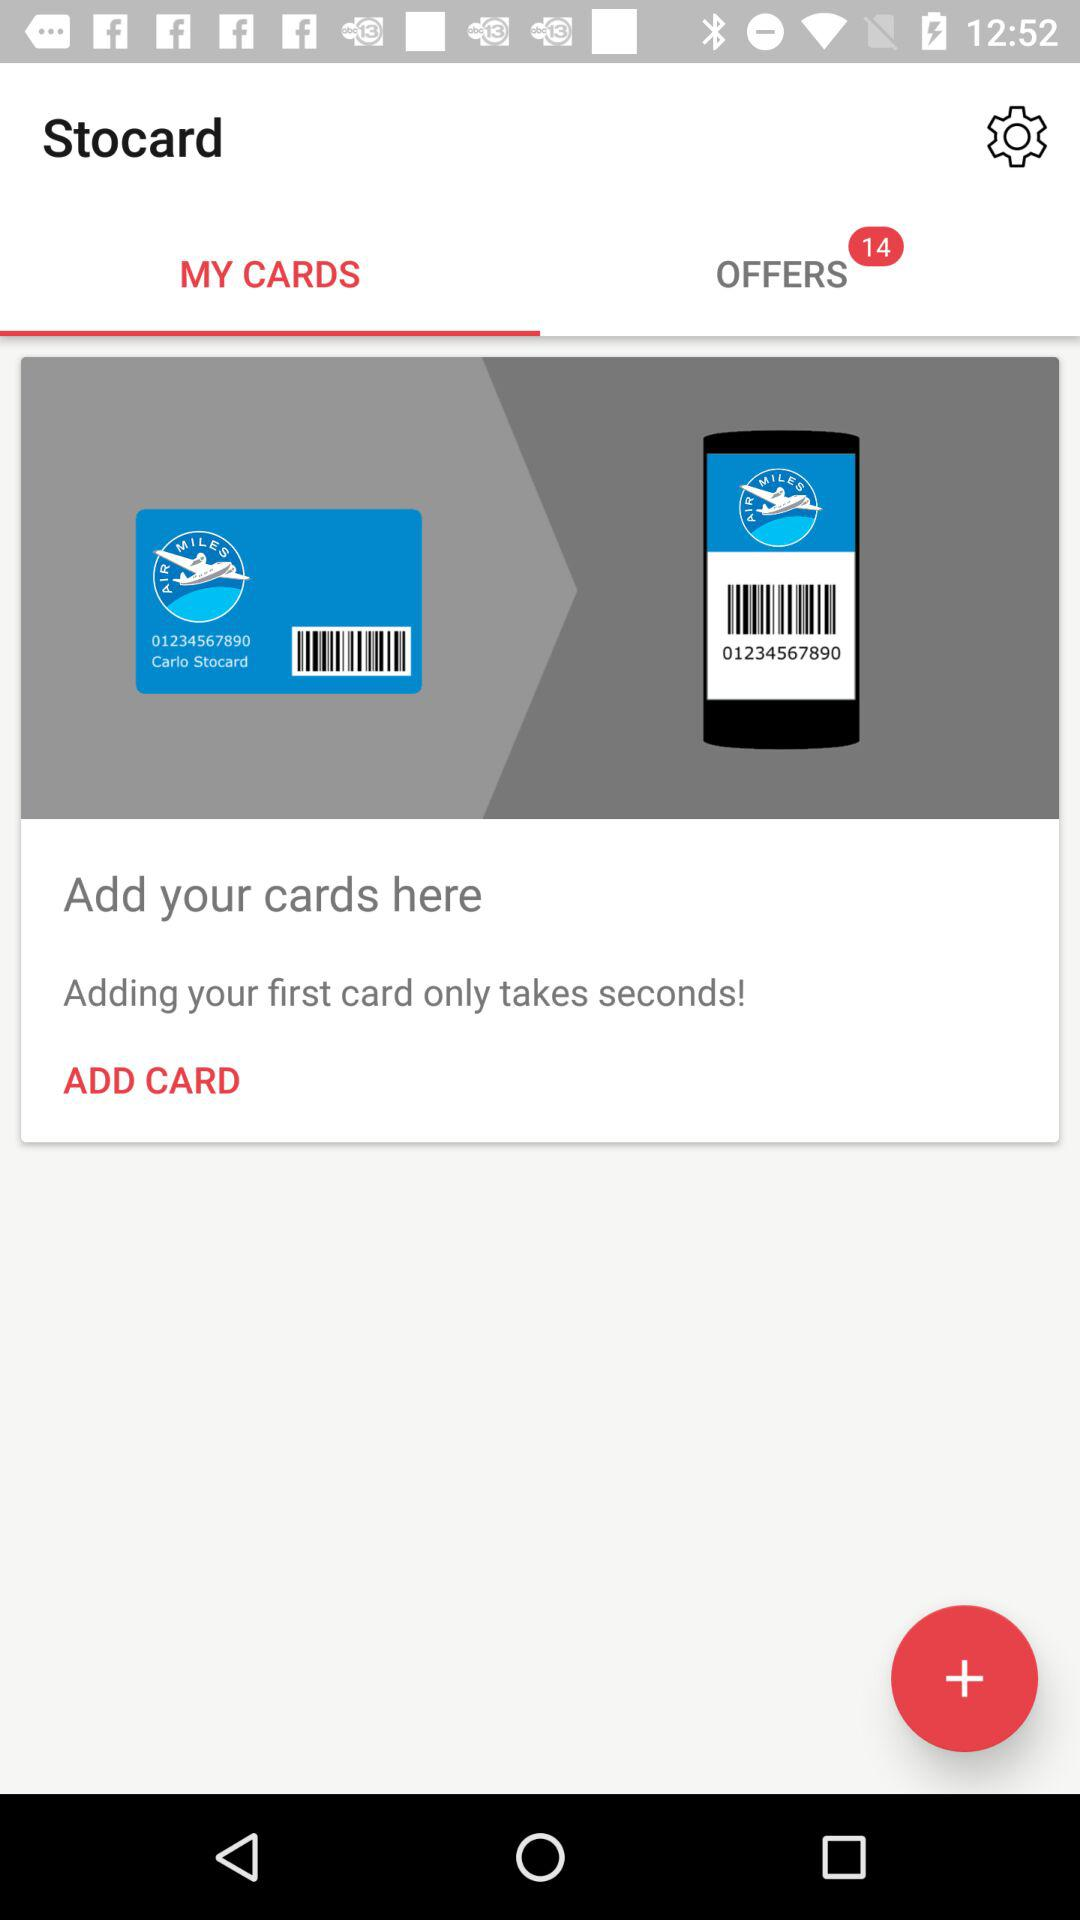How many notifications are there in "OFFERS"? There are 14 notifications in "OFFERS". 